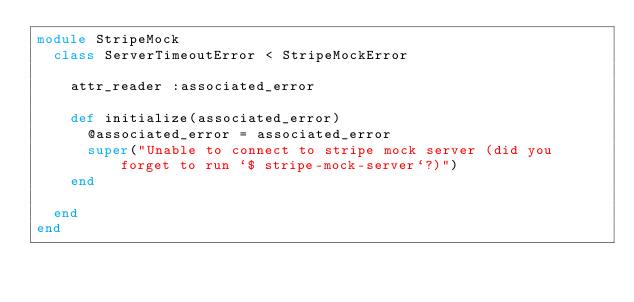Convert code to text. <code><loc_0><loc_0><loc_500><loc_500><_Ruby_>module StripeMock
  class ServerTimeoutError < StripeMockError

    attr_reader :associated_error

    def initialize(associated_error)
      @associated_error = associated_error
      super("Unable to connect to stripe mock server (did you forget to run `$ stripe-mock-server`?)")
    end

  end
end
</code> 